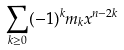<formula> <loc_0><loc_0><loc_500><loc_500>\sum _ { k \geq 0 } ( - 1 ) ^ { k } m _ { k } x ^ { n - 2 k }</formula> 